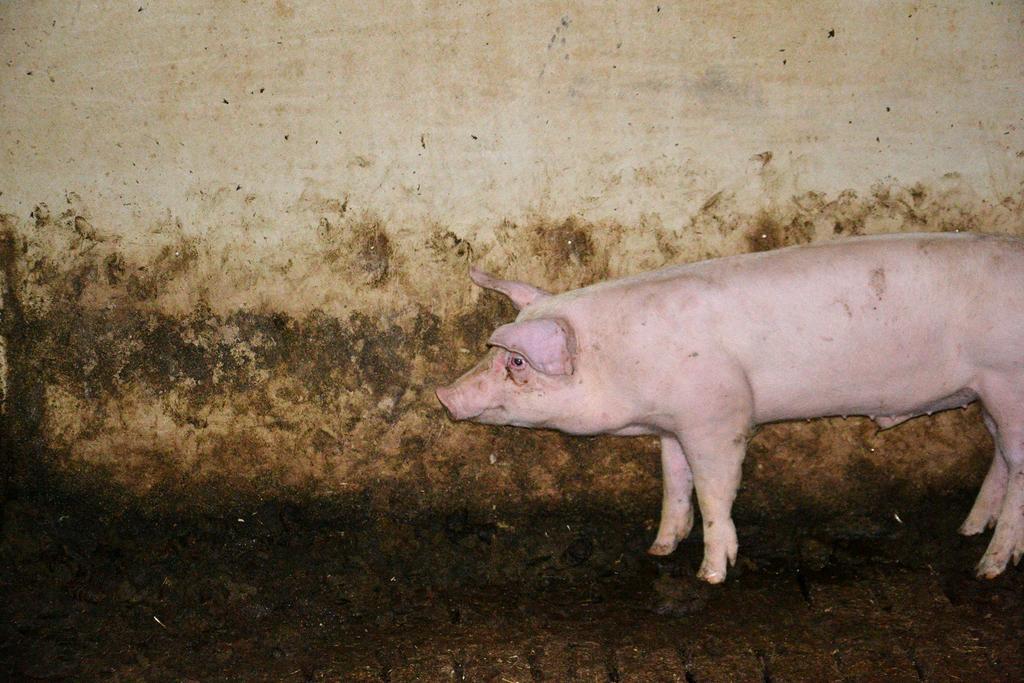Please provide a concise description of this image. In this picture I can see a pig and a wall in the background. 